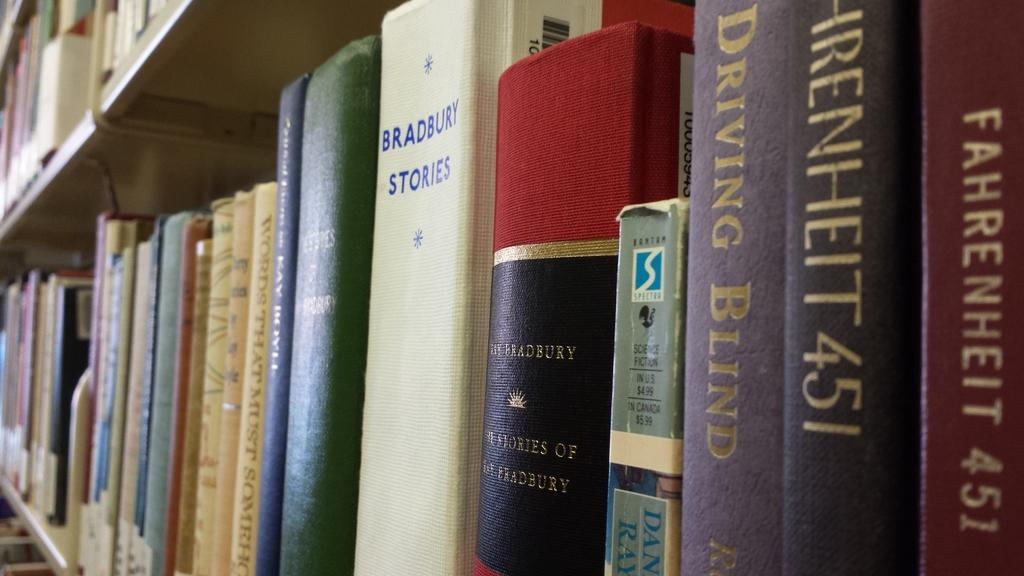<image>
Present a compact description of the photo's key features. A row of library books including two copies of Farenheit 451. 